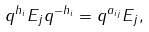<formula> <loc_0><loc_0><loc_500><loc_500>q ^ { h _ { i } } E _ { j } q ^ { - h _ { i } } = q ^ { a _ { i j } } E _ { j } ,</formula> 